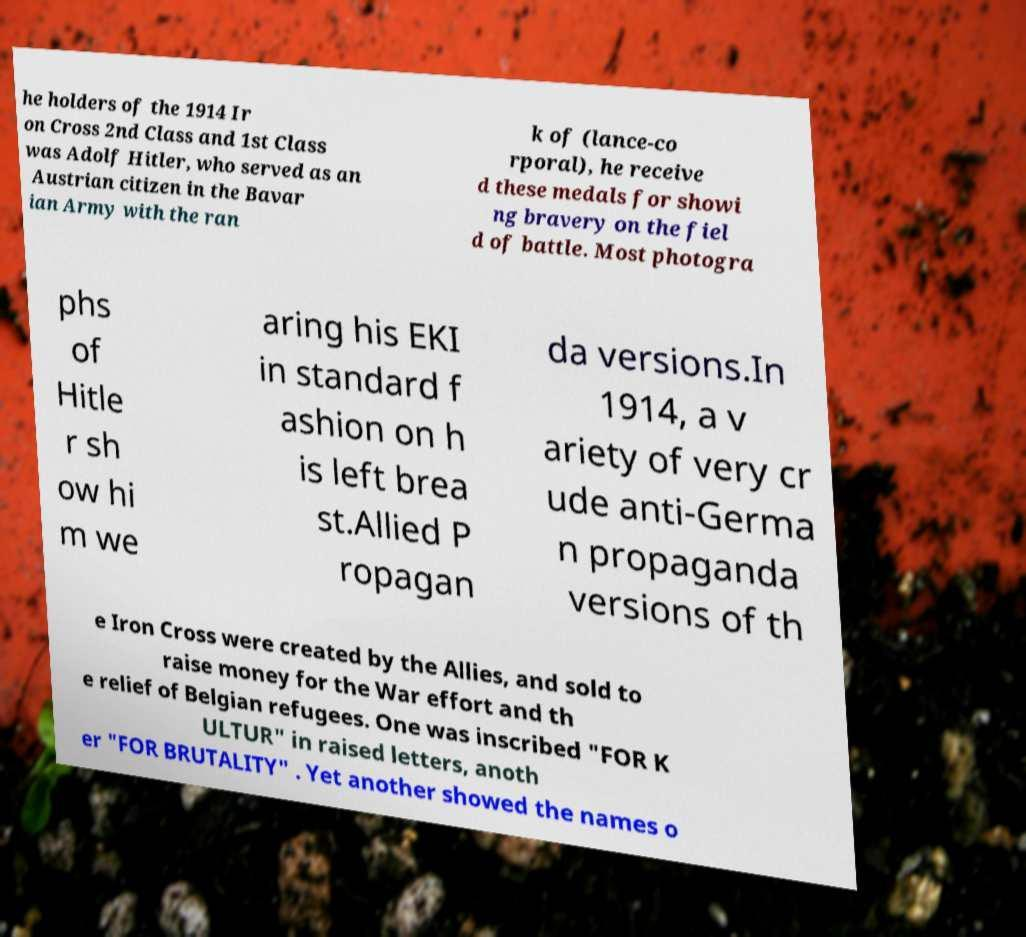Please identify and transcribe the text found in this image. he holders of the 1914 Ir on Cross 2nd Class and 1st Class was Adolf Hitler, who served as an Austrian citizen in the Bavar ian Army with the ran k of (lance-co rporal), he receive d these medals for showi ng bravery on the fiel d of battle. Most photogra phs of Hitle r sh ow hi m we aring his EKI in standard f ashion on h is left brea st.Allied P ropagan da versions.In 1914, a v ariety of very cr ude anti-Germa n propaganda versions of th e Iron Cross were created by the Allies, and sold to raise money for the War effort and th e relief of Belgian refugees. One was inscribed "FOR K ULTUR" in raised letters, anoth er "FOR BRUTALITY" . Yet another showed the names o 